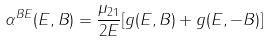Convert formula to latex. <formula><loc_0><loc_0><loc_500><loc_500>\alpha ^ { B E } ( E , B ) = \frac { \mu _ { 2 1 } } { 2 E } [ g ( E , B ) + g ( E , - B ) ]</formula> 